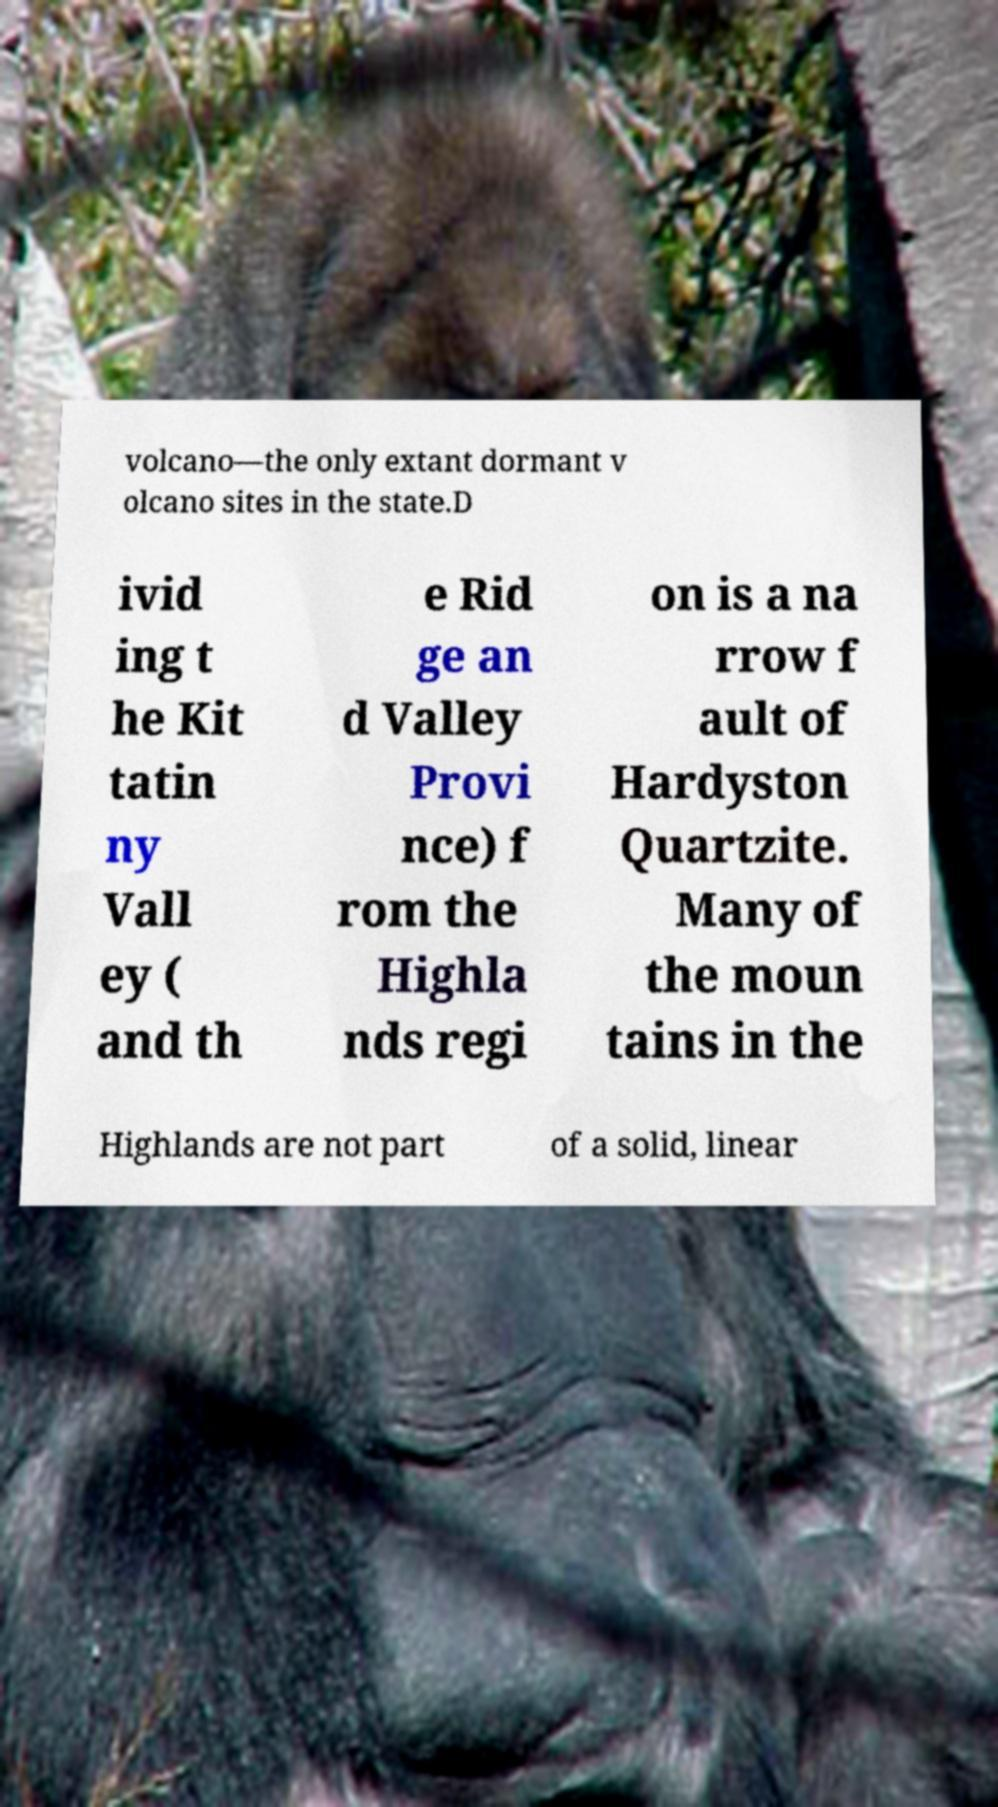Can you accurately transcribe the text from the provided image for me? volcano—the only extant dormant v olcano sites in the state.D ivid ing t he Kit tatin ny Vall ey ( and th e Rid ge an d Valley Provi nce) f rom the Highla nds regi on is a na rrow f ault of Hardyston Quartzite. Many of the moun tains in the Highlands are not part of a solid, linear 